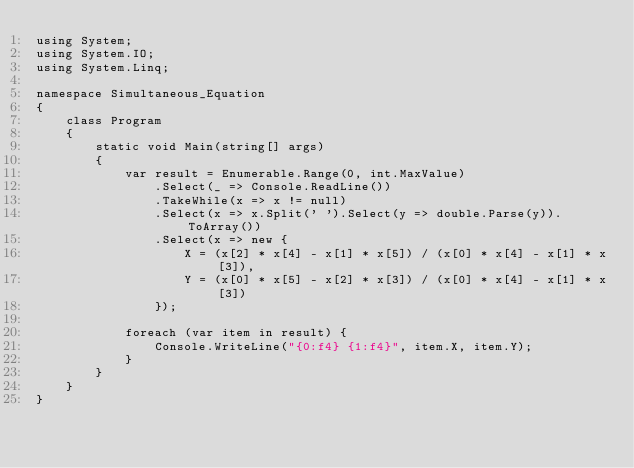Convert code to text. <code><loc_0><loc_0><loc_500><loc_500><_C#_>using System;
using System.IO;
using System.Linq;

namespace Simultaneous_Equation
{
	class Program
	{
		static void Main(string[] args)
		{
			var result = Enumerable.Range(0, int.MaxValue)
				.Select(_ => Console.ReadLine())
				.TakeWhile(x => x != null)
				.Select(x => x.Split(' ').Select(y => double.Parse(y)).ToArray())
				.Select(x => new {
					X = (x[2] * x[4] - x[1] * x[5]) / (x[0] * x[4] - x[1] * x[3]),
					Y = (x[0] * x[5] - x[2] * x[3]) / (x[0] * x[4] - x[1] * x[3])
				});

			foreach (var item in result) {
				Console.WriteLine("{0:f4} {1:f4}", item.X, item.Y);
			}
		}
	}
}</code> 